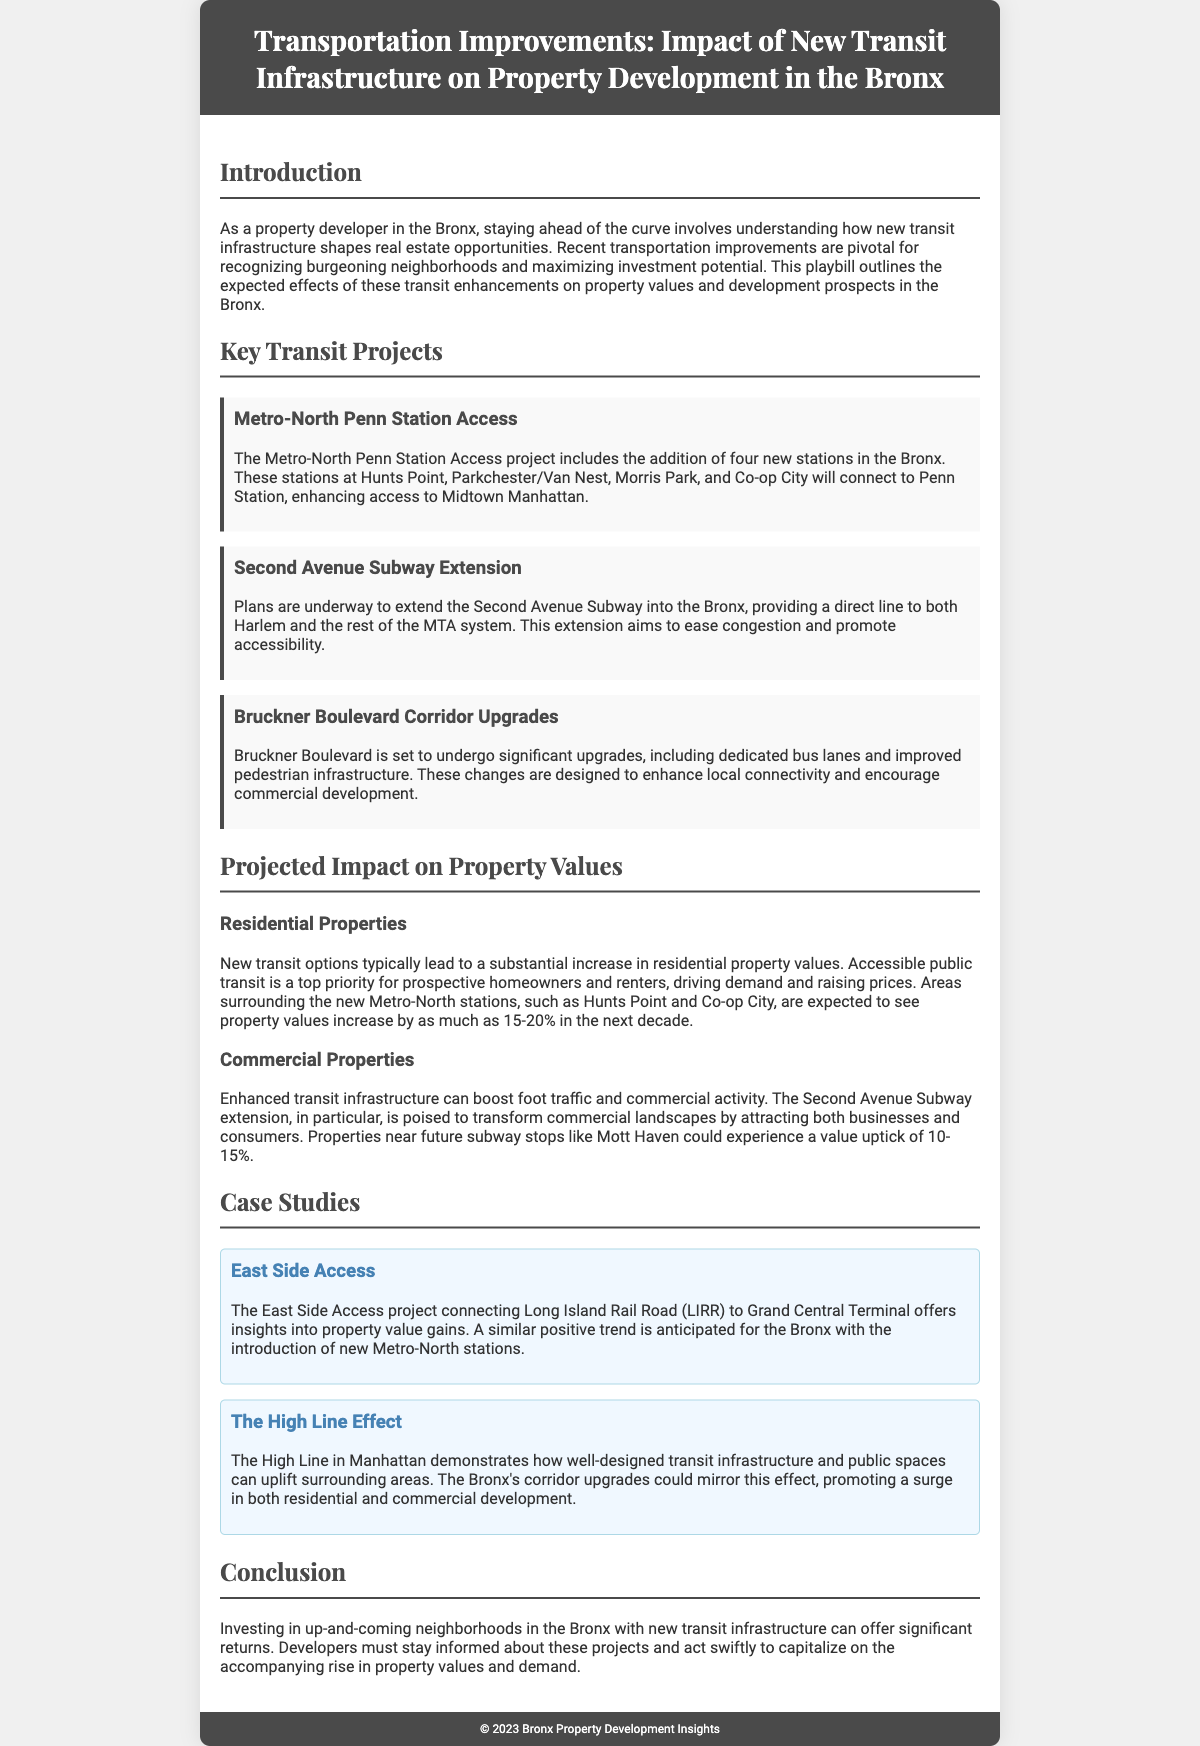What are the names of the new Metro-North stations? The new Metro-North stations mentioned are Hunts Point, Parkchester/Van Nest, Morris Park, and Co-op City.
Answer: Hunts Point, Parkchester/Van Nest, Morris Park, Co-op City What is the projected property value increase for areas surrounding the new Metro-North stations? The document indicates that properties in these areas are expected to increase by 15-20% in the next decade.
Answer: 15-20% What transportation project is aimed at relieving congestion in the Bronx? The Second Avenue Subway Extension is identified as a project intended to ease congestion and improve accessibility.
Answer: Second Avenue Subway Extension What effect did the East Side Access project have on property values? The case study indicates a similar positive trend is anticipated for the Bronx with the introduction of new Metro-North stations.
Answer: Positive trend anticipated Which neighborhoods are expected to see an uptick in commercial property values? The document mentions Mott Haven as a neighborhood likely to experience a value increase due to the Second Avenue Subway extension.
Answer: Mott Haven What type of infrastructure upgrades are planned for Bruckner Boulevard? Bruckner Boulevard will undergo upgrades including dedicated bus lanes and improved pedestrian infrastructure.
Answer: Dedicated bus lanes and improved pedestrian infrastructure How much is the expected increase for commercial properties near future subway stops? According to the document, properties near future subway stops could experience a value uptick of 10-15%.
Answer: 10-15% What should developers do to capitalize on new transit infrastructure? Developers are advised to stay informed about the projects and act swiftly to capitalize on these developments.
Answer: Stay informed and act swiftly 